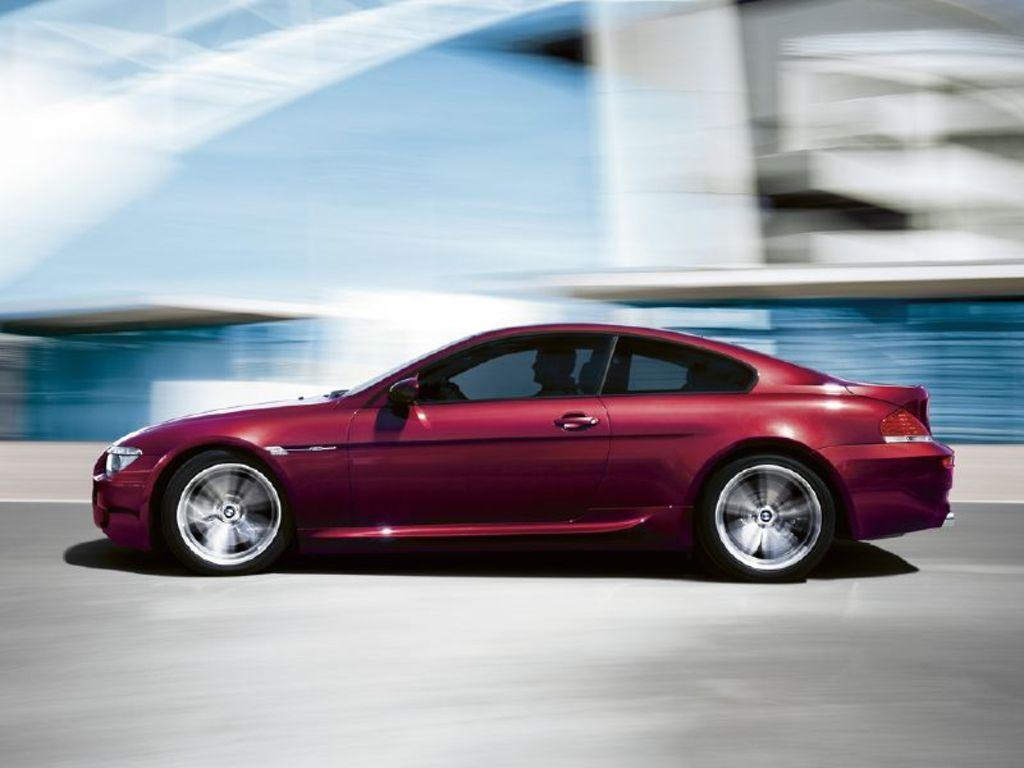Please provide a concise description of this image. In this image we can see a car on the road. The background is blurry. 